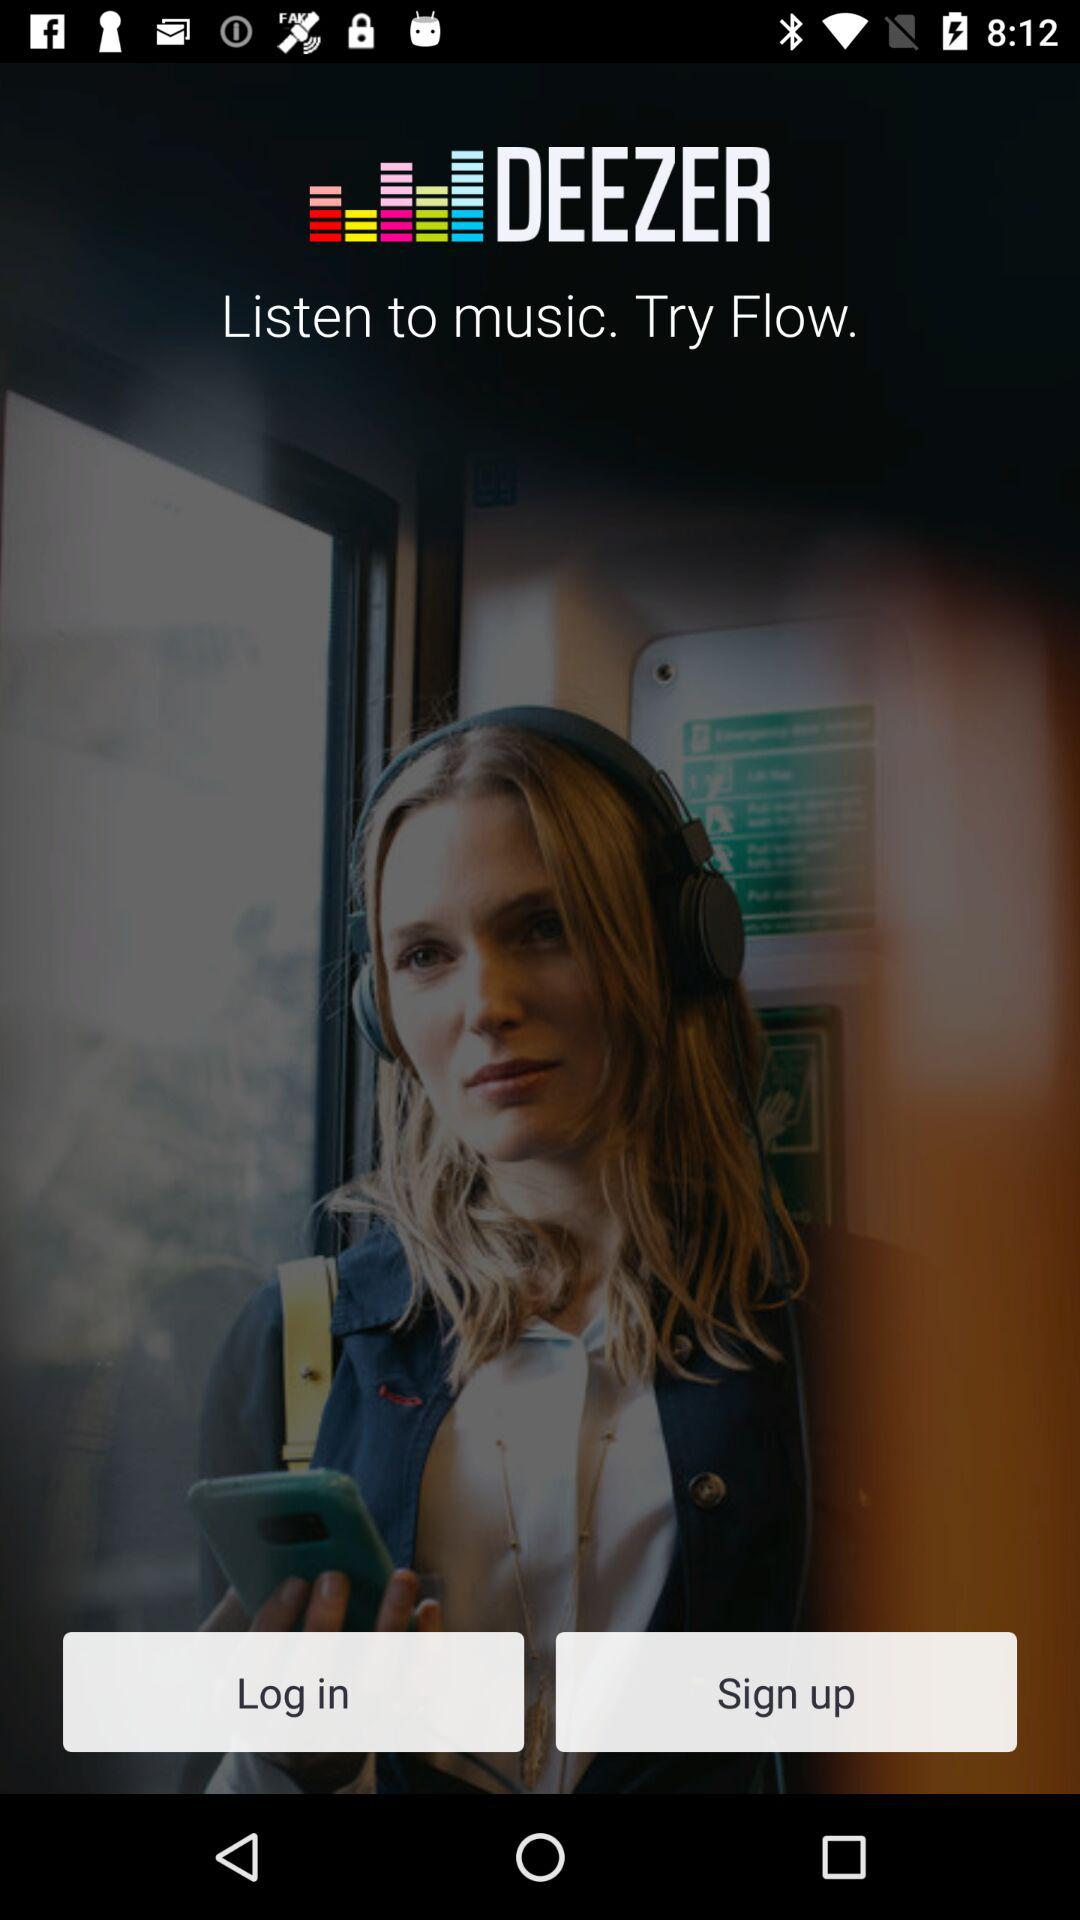What is the application name? The application name is "DEEZER". 